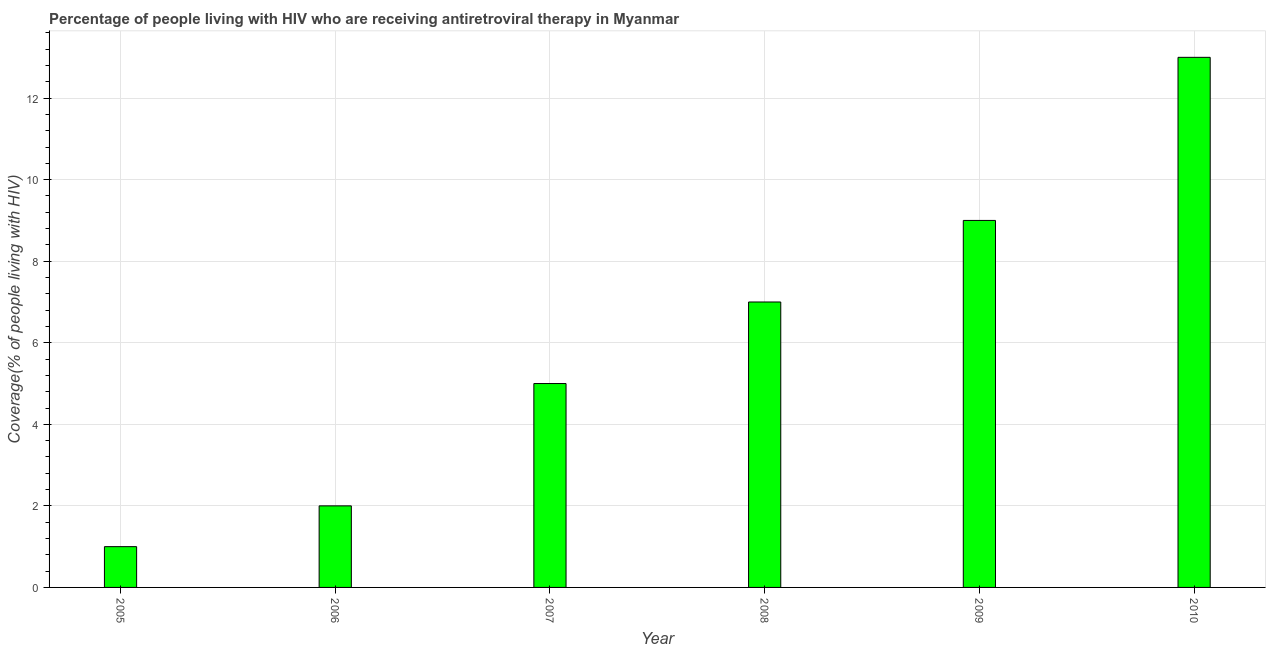Does the graph contain any zero values?
Make the answer very short. No. Does the graph contain grids?
Your response must be concise. Yes. What is the title of the graph?
Offer a terse response. Percentage of people living with HIV who are receiving antiretroviral therapy in Myanmar. What is the label or title of the Y-axis?
Make the answer very short. Coverage(% of people living with HIV). What is the antiretroviral therapy coverage in 2007?
Your answer should be very brief. 5. In which year was the antiretroviral therapy coverage minimum?
Provide a short and direct response. 2005. What is the difference between the antiretroviral therapy coverage in 2005 and 2010?
Offer a very short reply. -12. What is the median antiretroviral therapy coverage?
Your answer should be very brief. 6. Do a majority of the years between 2007 and 2010 (inclusive) have antiretroviral therapy coverage greater than 6 %?
Offer a terse response. Yes. What is the ratio of the antiretroviral therapy coverage in 2007 to that in 2010?
Offer a very short reply. 0.39. Is the difference between the antiretroviral therapy coverage in 2005 and 2006 greater than the difference between any two years?
Provide a short and direct response. No. Is the sum of the antiretroviral therapy coverage in 2006 and 2010 greater than the maximum antiretroviral therapy coverage across all years?
Ensure brevity in your answer.  Yes. What is the difference between the highest and the lowest antiretroviral therapy coverage?
Your answer should be very brief. 12. Are all the bars in the graph horizontal?
Keep it short and to the point. No. What is the difference between two consecutive major ticks on the Y-axis?
Your answer should be compact. 2. Are the values on the major ticks of Y-axis written in scientific E-notation?
Ensure brevity in your answer.  No. What is the Coverage(% of people living with HIV) in 2006?
Provide a succinct answer. 2. What is the Coverage(% of people living with HIV) of 2007?
Give a very brief answer. 5. What is the difference between the Coverage(% of people living with HIV) in 2005 and 2006?
Your answer should be compact. -1. What is the difference between the Coverage(% of people living with HIV) in 2005 and 2007?
Give a very brief answer. -4. What is the difference between the Coverage(% of people living with HIV) in 2005 and 2010?
Provide a short and direct response. -12. What is the difference between the Coverage(% of people living with HIV) in 2006 and 2008?
Ensure brevity in your answer.  -5. What is the difference between the Coverage(% of people living with HIV) in 2006 and 2009?
Keep it short and to the point. -7. What is the difference between the Coverage(% of people living with HIV) in 2006 and 2010?
Your response must be concise. -11. What is the difference between the Coverage(% of people living with HIV) in 2007 and 2010?
Your response must be concise. -8. What is the difference between the Coverage(% of people living with HIV) in 2008 and 2009?
Make the answer very short. -2. What is the difference between the Coverage(% of people living with HIV) in 2008 and 2010?
Your response must be concise. -6. What is the difference between the Coverage(% of people living with HIV) in 2009 and 2010?
Give a very brief answer. -4. What is the ratio of the Coverage(% of people living with HIV) in 2005 to that in 2008?
Your answer should be very brief. 0.14. What is the ratio of the Coverage(% of people living with HIV) in 2005 to that in 2009?
Offer a very short reply. 0.11. What is the ratio of the Coverage(% of people living with HIV) in 2005 to that in 2010?
Provide a short and direct response. 0.08. What is the ratio of the Coverage(% of people living with HIV) in 2006 to that in 2007?
Provide a succinct answer. 0.4. What is the ratio of the Coverage(% of people living with HIV) in 2006 to that in 2008?
Offer a terse response. 0.29. What is the ratio of the Coverage(% of people living with HIV) in 2006 to that in 2009?
Keep it short and to the point. 0.22. What is the ratio of the Coverage(% of people living with HIV) in 2006 to that in 2010?
Offer a terse response. 0.15. What is the ratio of the Coverage(% of people living with HIV) in 2007 to that in 2008?
Provide a short and direct response. 0.71. What is the ratio of the Coverage(% of people living with HIV) in 2007 to that in 2009?
Make the answer very short. 0.56. What is the ratio of the Coverage(% of people living with HIV) in 2007 to that in 2010?
Give a very brief answer. 0.39. What is the ratio of the Coverage(% of people living with HIV) in 2008 to that in 2009?
Provide a short and direct response. 0.78. What is the ratio of the Coverage(% of people living with HIV) in 2008 to that in 2010?
Offer a very short reply. 0.54. What is the ratio of the Coverage(% of people living with HIV) in 2009 to that in 2010?
Offer a terse response. 0.69. 